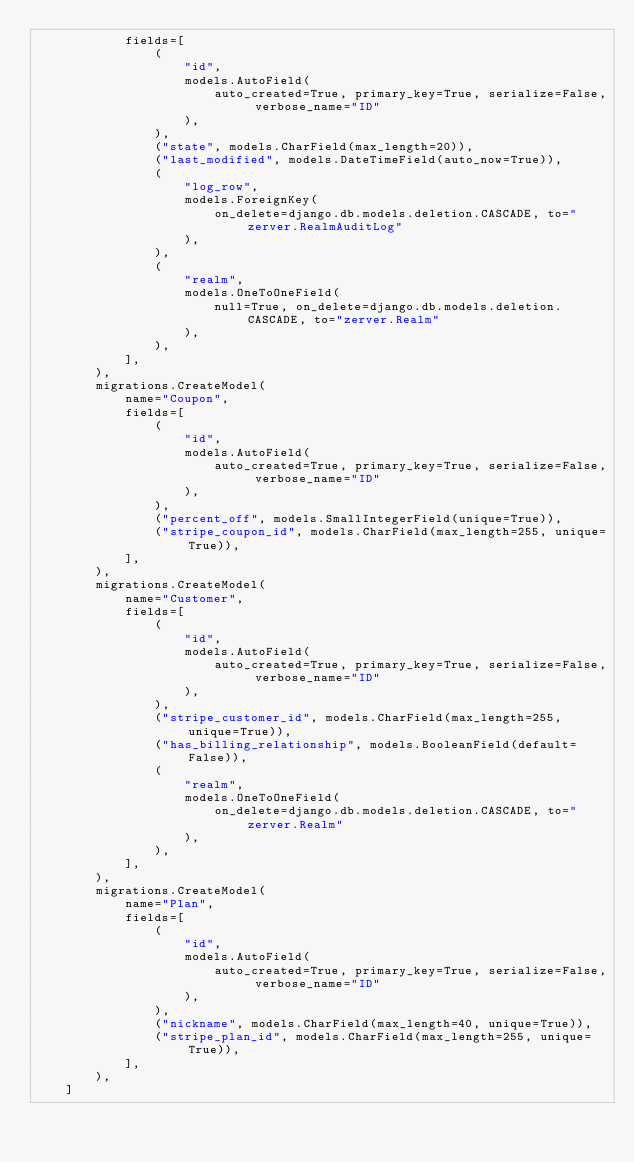Convert code to text. <code><loc_0><loc_0><loc_500><loc_500><_Python_>            fields=[
                (
                    "id",
                    models.AutoField(
                        auto_created=True, primary_key=True, serialize=False, verbose_name="ID"
                    ),
                ),
                ("state", models.CharField(max_length=20)),
                ("last_modified", models.DateTimeField(auto_now=True)),
                (
                    "log_row",
                    models.ForeignKey(
                        on_delete=django.db.models.deletion.CASCADE, to="zerver.RealmAuditLog"
                    ),
                ),
                (
                    "realm",
                    models.OneToOneField(
                        null=True, on_delete=django.db.models.deletion.CASCADE, to="zerver.Realm"
                    ),
                ),
            ],
        ),
        migrations.CreateModel(
            name="Coupon",
            fields=[
                (
                    "id",
                    models.AutoField(
                        auto_created=True, primary_key=True, serialize=False, verbose_name="ID"
                    ),
                ),
                ("percent_off", models.SmallIntegerField(unique=True)),
                ("stripe_coupon_id", models.CharField(max_length=255, unique=True)),
            ],
        ),
        migrations.CreateModel(
            name="Customer",
            fields=[
                (
                    "id",
                    models.AutoField(
                        auto_created=True, primary_key=True, serialize=False, verbose_name="ID"
                    ),
                ),
                ("stripe_customer_id", models.CharField(max_length=255, unique=True)),
                ("has_billing_relationship", models.BooleanField(default=False)),
                (
                    "realm",
                    models.OneToOneField(
                        on_delete=django.db.models.deletion.CASCADE, to="zerver.Realm"
                    ),
                ),
            ],
        ),
        migrations.CreateModel(
            name="Plan",
            fields=[
                (
                    "id",
                    models.AutoField(
                        auto_created=True, primary_key=True, serialize=False, verbose_name="ID"
                    ),
                ),
                ("nickname", models.CharField(max_length=40, unique=True)),
                ("stripe_plan_id", models.CharField(max_length=255, unique=True)),
            ],
        ),
    ]
</code> 